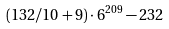Convert formula to latex. <formula><loc_0><loc_0><loc_500><loc_500>( 1 3 2 / 1 0 + 9 ) \cdot 6 ^ { 2 0 9 } - 2 3 2</formula> 